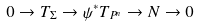<formula> <loc_0><loc_0><loc_500><loc_500>0 \rightarrow T _ { \Sigma } \rightarrow \psi ^ { * } T _ { P ^ { n } } \rightarrow N \rightarrow 0</formula> 